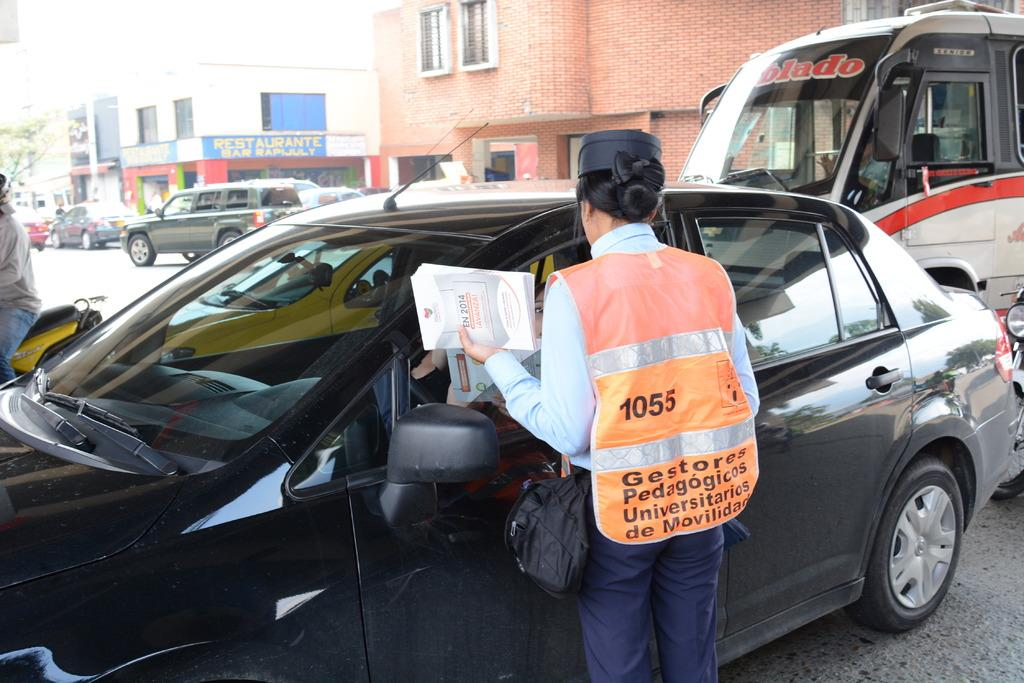<image>
Give a short and clear explanation of the subsequent image. a vest with the number 1055 on the back of it 